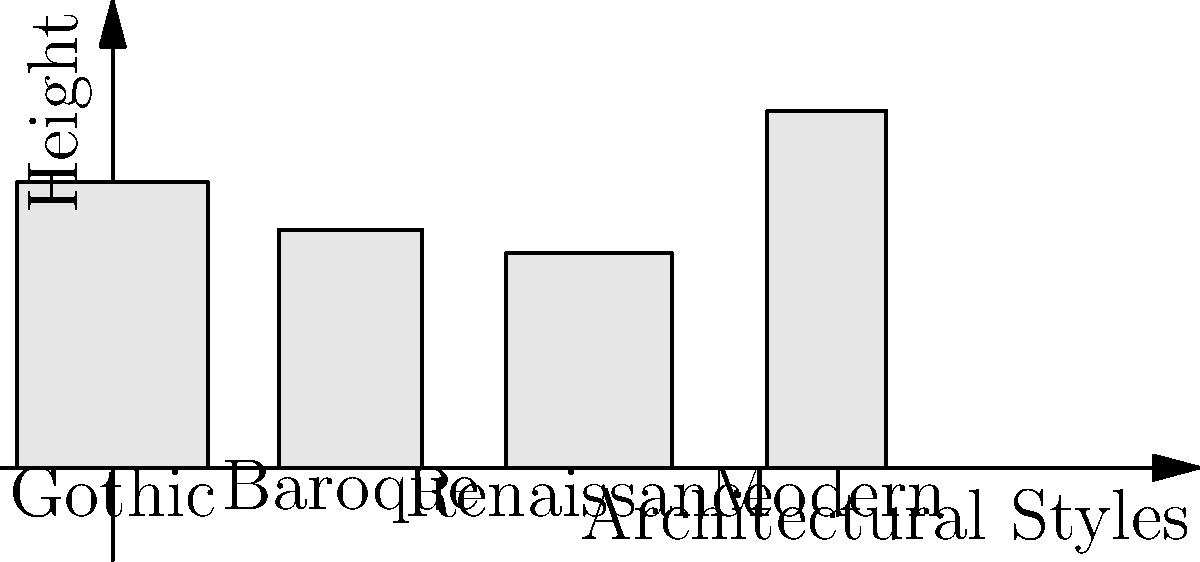As an Artem teacher passionate about global stories, you're discussing famous landmarks with your students. Which architectural style, represented in the graph, is characterized by its emphasis on vertical lines, pointed arches, and often features flying buttresses? To answer this question, let's analyze the characteristics of each architectural style represented in the graph:

1. Gothic architecture:
   - Emphasizes vertical lines and height
   - Known for pointed arches and flying buttresses
   - Often seen in medieval cathedrals
   - Represented by the tallest building in the graph

2. Baroque architecture:
   - Characterized by ornate decorations and dramatic effects
   - Often features curved lines and elaborate sculptures
   - Doesn't typically emphasize vertical lines

3. Renaissance architecture:
   - Inspired by classical Greek and Roman styles
   - Emphasizes symmetry and proportion
   - Doesn't typically feature pointed arches or flying buttresses

4. Modern architecture:
   - Characterized by simplicity and functional design
   - Often uses materials like steel and glass
   - Doesn't typically feature ornate decorations or pointed arches

Based on the description in the question, which mentions "emphasis on vertical lines, pointed arches, and often features flying buttresses," the architectural style that best matches these characteristics is Gothic.
Answer: Gothic 